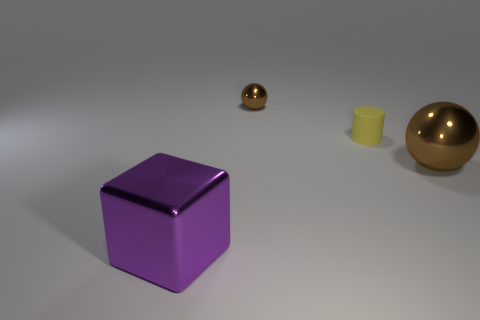How many green objects are metallic blocks or metal things?
Offer a terse response. 0. What material is the tiny brown object that is the same shape as the big brown metal thing?
Ensure brevity in your answer.  Metal. There is a large object that is behind the big purple shiny block; what shape is it?
Provide a succinct answer. Sphere. Are there any spheres that have the same material as the block?
Offer a terse response. Yes. How many cylinders are small yellow things or big blue metallic things?
Your response must be concise. 1. There is a small sphere that is the same color as the big shiny ball; what is its material?
Ensure brevity in your answer.  Metal. How many big objects are the same shape as the tiny yellow object?
Provide a succinct answer. 0. Are there more brown spheres to the left of the yellow rubber thing than brown objects that are behind the small brown object?
Make the answer very short. Yes. There is a large thing behind the purple shiny block; is its color the same as the small metallic ball?
Your answer should be compact. Yes. The purple metal thing has what size?
Offer a terse response. Large. 